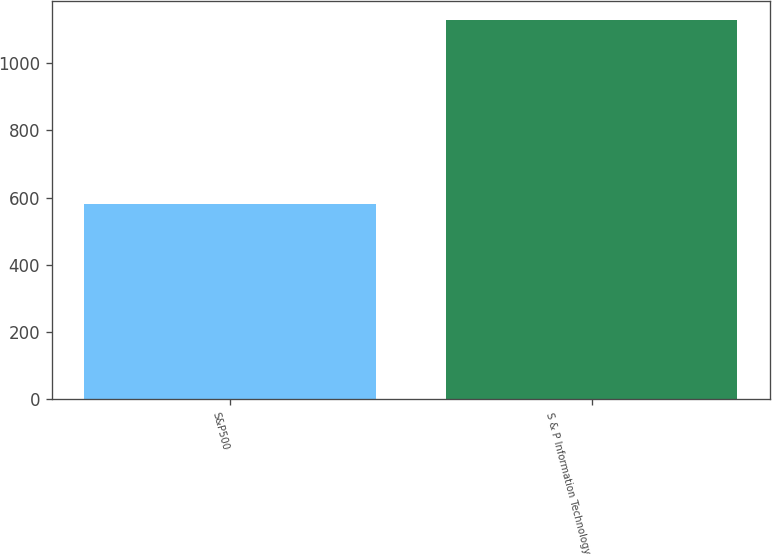Convert chart to OTSL. <chart><loc_0><loc_0><loc_500><loc_500><bar_chart><fcel>S&P500<fcel>S & P Information Technology<nl><fcel>582.6<fcel>1128.76<nl></chart> 